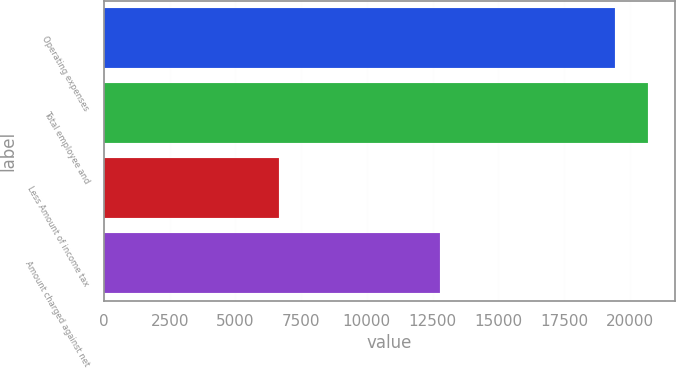Convert chart to OTSL. <chart><loc_0><loc_0><loc_500><loc_500><bar_chart><fcel>Operating expenses<fcel>Total employee and<fcel>Less Amount of income tax<fcel>Amount charged against net<nl><fcel>19424<fcel>20701.8<fcel>6646<fcel>12778<nl></chart> 